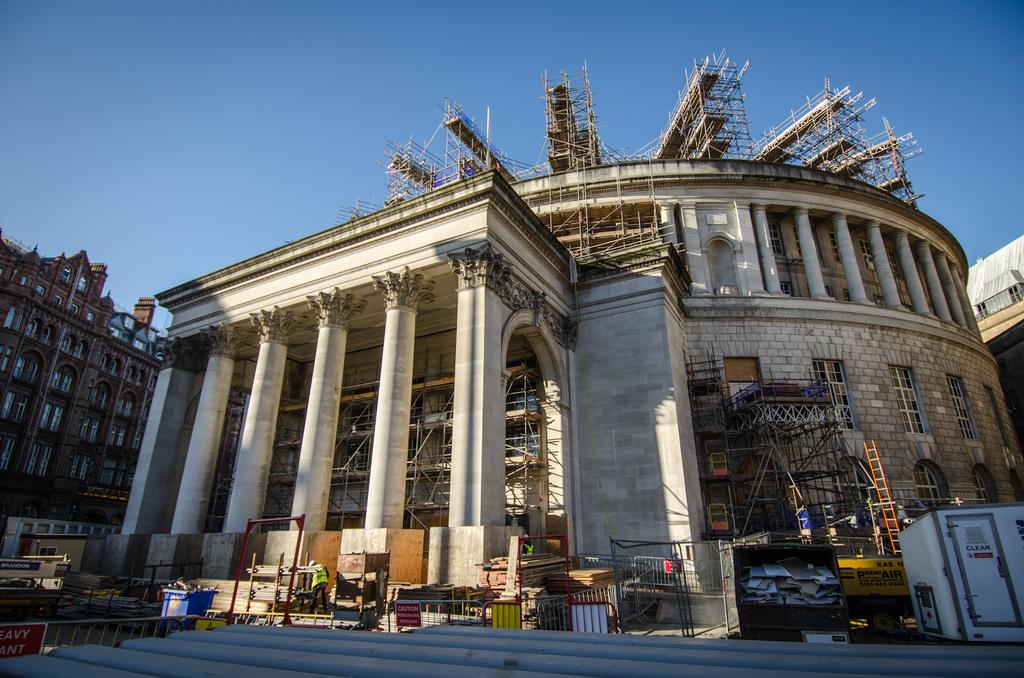What is the main subject of the image? The image shows a place under construction. What can be seen among the construction materials? There are many pillars and poles in the image. What tool is visible in the image for reaching higher places? A ladder is visible in the image. What can be seen in the background of the image? There are other buildings in the background of the image. What is the color of the sky in the image? The sky is blue in the image. Can you see any waves crashing against the shore in the image? There are no waves or shore visible in the image; it shows a construction site with buildings and sky. What type of collar is being used to secure the poles in the image? There is no collar present in the image; it shows a construction site with pillars, poles, and a ladder. 